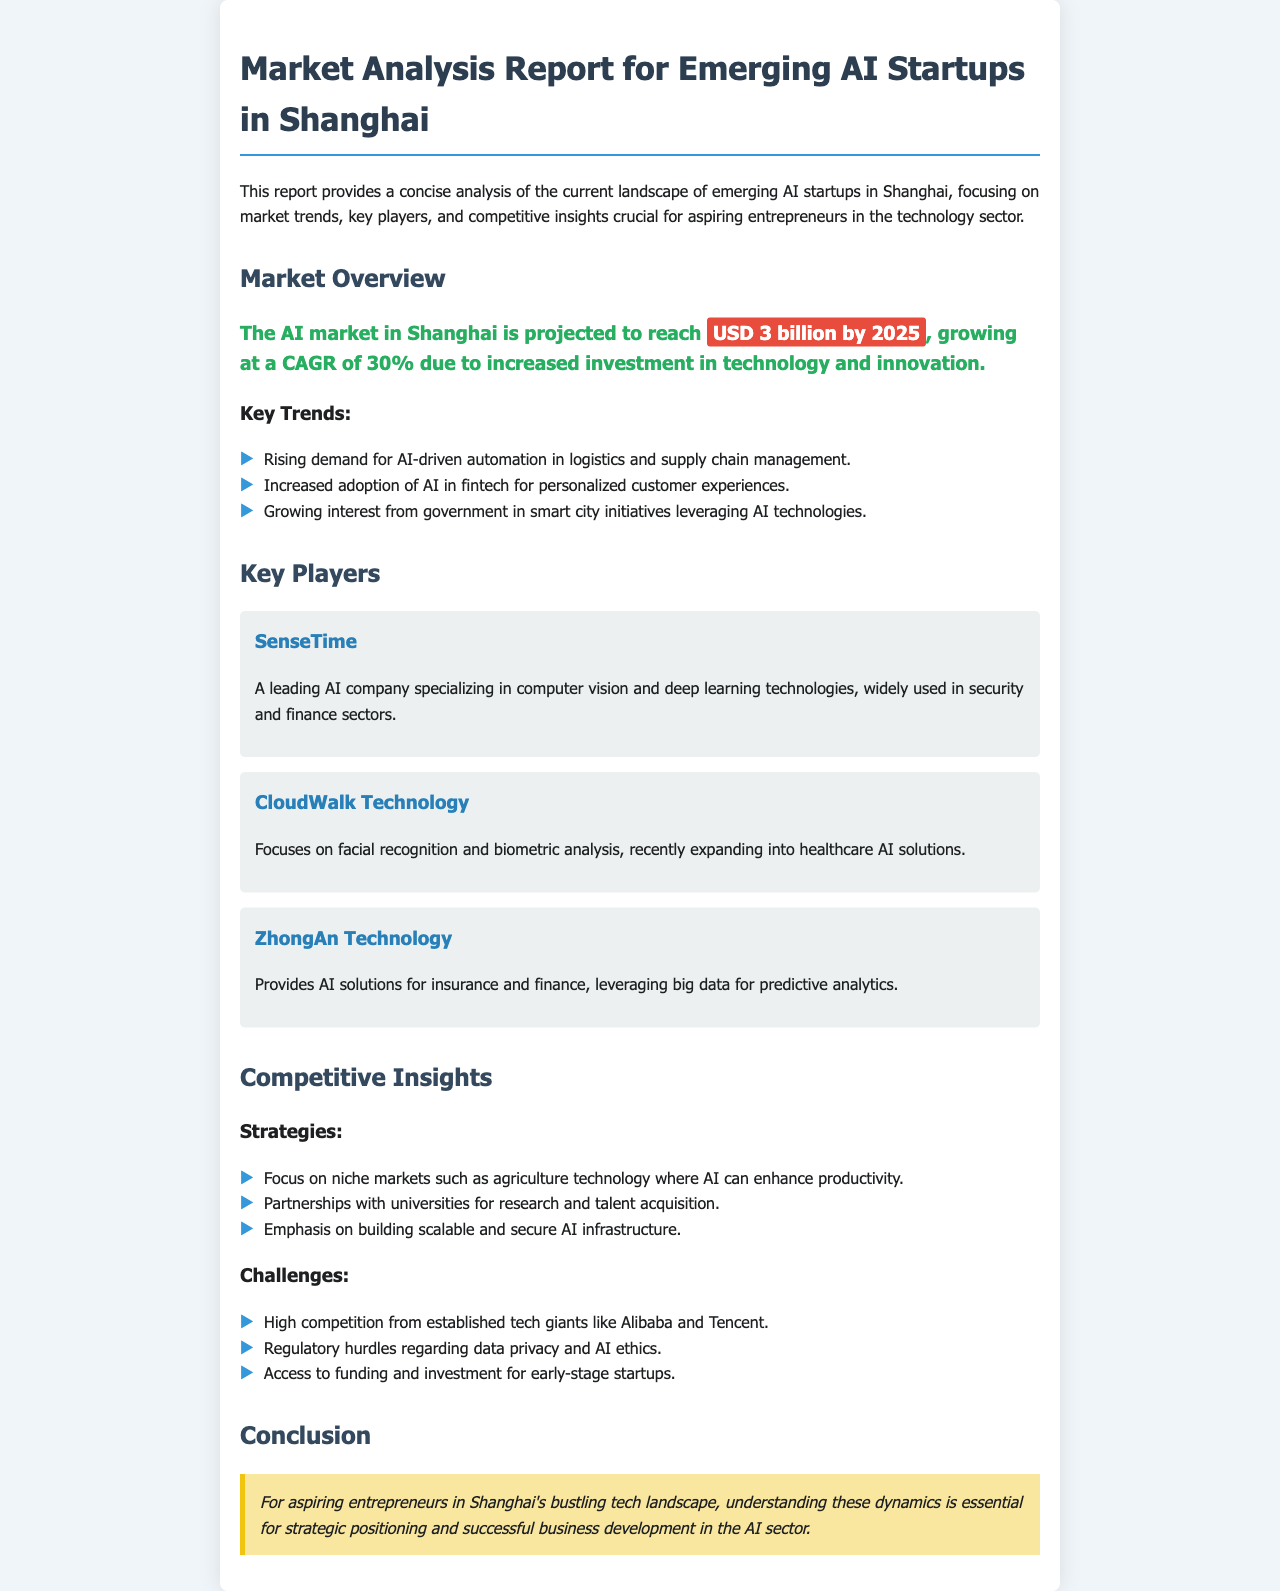What is the projected market size for AI in Shanghai by 2025? The document states the AI market in Shanghai is projected to reach USD 3 billion by 2025.
Answer: USD 3 billion What is the CAGR for the AI market in Shanghai? The document mentions the market is growing at a CAGR of 30%.
Answer: 30% Which company specializes in computer vision and deep learning technologies? The report identifies SenseTime as a leading AI company specializing in these technologies.
Answer: SenseTime What is a key strategy for emerging AI startups mentioned in the report? The document lists focusing on niche markets such as agriculture technology as a key strategy for startups.
Answer: Focus on niche markets What major challenge do early-stage AI startups face? The document highlights access to funding and investment as a significant challenge.
Answer: Access to funding What trend is driving the adoption of AI in fintech? The report states that the increased adoption is for personalized customer experiences.
Answer: Personalized customer experiences Who provides AI solutions for insurance and finance? The report mentions ZhongAn Technology as a provider of AI solutions in this sector.
Answer: ZhongAn Technology What color is used for highlighting market size in the report? The market size is highlighted with a background color of red in the document.
Answer: Red Which technology company is expanding into healthcare AI solutions? The document identifies CloudWalk Technology as focusing on healthcare AI solutions.
Answer: CloudWalk Technology 